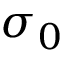Convert formula to latex. <formula><loc_0><loc_0><loc_500><loc_500>\sigma _ { 0 }</formula> 